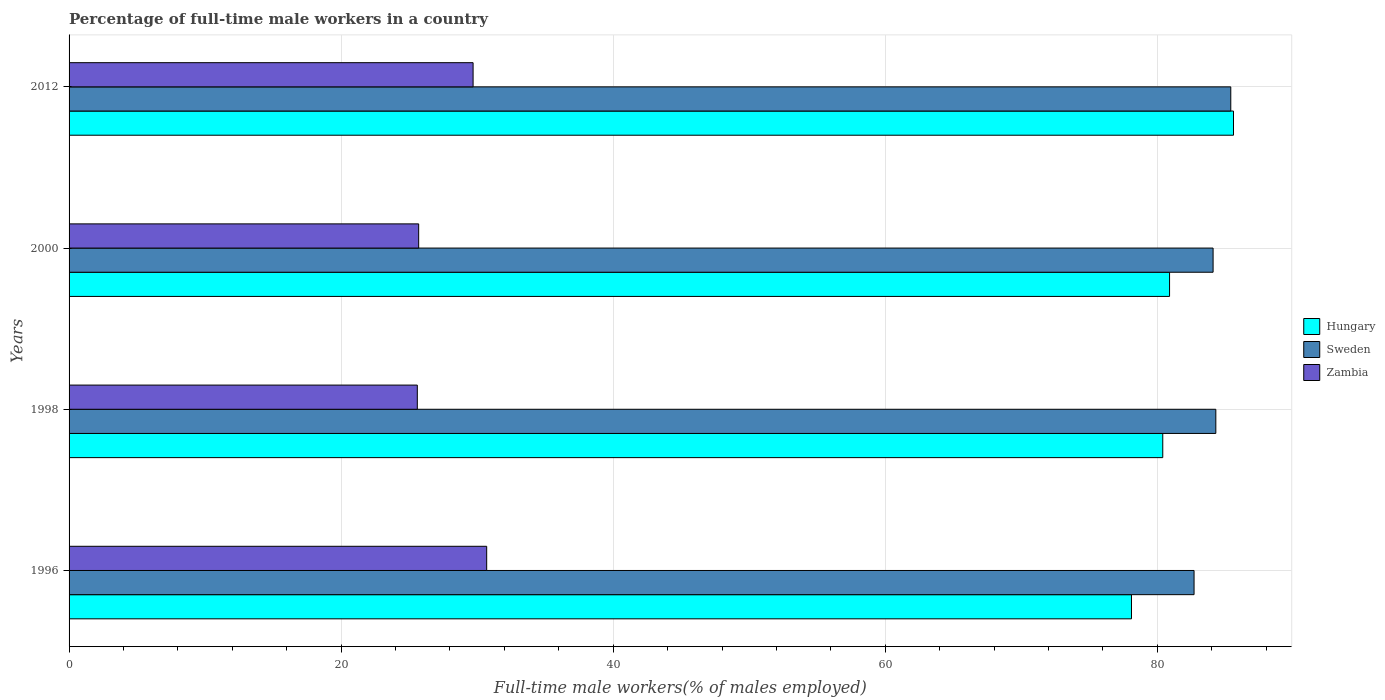How many different coloured bars are there?
Ensure brevity in your answer.  3. Are the number of bars on each tick of the Y-axis equal?
Keep it short and to the point. Yes. How many bars are there on the 4th tick from the top?
Keep it short and to the point. 3. How many bars are there on the 2nd tick from the bottom?
Your response must be concise. 3. What is the percentage of full-time male workers in Zambia in 1996?
Ensure brevity in your answer.  30.7. Across all years, what is the maximum percentage of full-time male workers in Sweden?
Your answer should be very brief. 85.4. Across all years, what is the minimum percentage of full-time male workers in Zambia?
Your response must be concise. 25.6. In which year was the percentage of full-time male workers in Zambia maximum?
Offer a very short reply. 1996. In which year was the percentage of full-time male workers in Sweden minimum?
Provide a succinct answer. 1996. What is the total percentage of full-time male workers in Sweden in the graph?
Provide a succinct answer. 336.5. What is the difference between the percentage of full-time male workers in Zambia in 2000 and the percentage of full-time male workers in Sweden in 1998?
Keep it short and to the point. -58.6. What is the average percentage of full-time male workers in Sweden per year?
Provide a short and direct response. 84.12. In the year 1996, what is the difference between the percentage of full-time male workers in Zambia and percentage of full-time male workers in Hungary?
Provide a succinct answer. -47.4. In how many years, is the percentage of full-time male workers in Zambia greater than 64 %?
Offer a very short reply. 0. What is the ratio of the percentage of full-time male workers in Zambia in 1996 to that in 2000?
Offer a very short reply. 1.19. Is the percentage of full-time male workers in Hungary in 2000 less than that in 2012?
Give a very brief answer. Yes. What is the difference between the highest and the second highest percentage of full-time male workers in Zambia?
Offer a very short reply. 1. What is the difference between the highest and the lowest percentage of full-time male workers in Hungary?
Give a very brief answer. 7.5. In how many years, is the percentage of full-time male workers in Sweden greater than the average percentage of full-time male workers in Sweden taken over all years?
Provide a succinct answer. 2. What does the 3rd bar from the top in 2000 represents?
Your answer should be very brief. Hungary. What does the 3rd bar from the bottom in 2012 represents?
Provide a succinct answer. Zambia. Are all the bars in the graph horizontal?
Offer a terse response. Yes. How many years are there in the graph?
Keep it short and to the point. 4. What is the difference between two consecutive major ticks on the X-axis?
Ensure brevity in your answer.  20. Does the graph contain grids?
Make the answer very short. Yes. How many legend labels are there?
Make the answer very short. 3. How are the legend labels stacked?
Offer a very short reply. Vertical. What is the title of the graph?
Ensure brevity in your answer.  Percentage of full-time male workers in a country. What is the label or title of the X-axis?
Give a very brief answer. Full-time male workers(% of males employed). What is the label or title of the Y-axis?
Make the answer very short. Years. What is the Full-time male workers(% of males employed) of Hungary in 1996?
Your response must be concise. 78.1. What is the Full-time male workers(% of males employed) of Sweden in 1996?
Keep it short and to the point. 82.7. What is the Full-time male workers(% of males employed) of Zambia in 1996?
Give a very brief answer. 30.7. What is the Full-time male workers(% of males employed) of Hungary in 1998?
Provide a succinct answer. 80.4. What is the Full-time male workers(% of males employed) of Sweden in 1998?
Offer a very short reply. 84.3. What is the Full-time male workers(% of males employed) of Zambia in 1998?
Your response must be concise. 25.6. What is the Full-time male workers(% of males employed) in Hungary in 2000?
Ensure brevity in your answer.  80.9. What is the Full-time male workers(% of males employed) of Sweden in 2000?
Offer a very short reply. 84.1. What is the Full-time male workers(% of males employed) in Zambia in 2000?
Give a very brief answer. 25.7. What is the Full-time male workers(% of males employed) in Hungary in 2012?
Make the answer very short. 85.6. What is the Full-time male workers(% of males employed) of Sweden in 2012?
Your answer should be very brief. 85.4. What is the Full-time male workers(% of males employed) in Zambia in 2012?
Provide a succinct answer. 29.7. Across all years, what is the maximum Full-time male workers(% of males employed) of Hungary?
Make the answer very short. 85.6. Across all years, what is the maximum Full-time male workers(% of males employed) of Sweden?
Your response must be concise. 85.4. Across all years, what is the maximum Full-time male workers(% of males employed) in Zambia?
Your answer should be compact. 30.7. Across all years, what is the minimum Full-time male workers(% of males employed) of Hungary?
Give a very brief answer. 78.1. Across all years, what is the minimum Full-time male workers(% of males employed) of Sweden?
Keep it short and to the point. 82.7. Across all years, what is the minimum Full-time male workers(% of males employed) in Zambia?
Your answer should be very brief. 25.6. What is the total Full-time male workers(% of males employed) in Hungary in the graph?
Provide a short and direct response. 325. What is the total Full-time male workers(% of males employed) in Sweden in the graph?
Your answer should be compact. 336.5. What is the total Full-time male workers(% of males employed) of Zambia in the graph?
Provide a succinct answer. 111.7. What is the difference between the Full-time male workers(% of males employed) in Hungary in 1996 and that in 1998?
Your response must be concise. -2.3. What is the difference between the Full-time male workers(% of males employed) in Sweden in 1996 and that in 1998?
Provide a succinct answer. -1.6. What is the difference between the Full-time male workers(% of males employed) in Zambia in 1996 and that in 1998?
Your response must be concise. 5.1. What is the difference between the Full-time male workers(% of males employed) in Sweden in 1996 and that in 2000?
Keep it short and to the point. -1.4. What is the difference between the Full-time male workers(% of males employed) in Zambia in 1996 and that in 2000?
Give a very brief answer. 5. What is the difference between the Full-time male workers(% of males employed) in Hungary in 1996 and that in 2012?
Keep it short and to the point. -7.5. What is the difference between the Full-time male workers(% of males employed) in Sweden in 1996 and that in 2012?
Provide a short and direct response. -2.7. What is the difference between the Full-time male workers(% of males employed) in Sweden in 1998 and that in 2000?
Your answer should be very brief. 0.2. What is the difference between the Full-time male workers(% of males employed) in Zambia in 1998 and that in 2000?
Offer a terse response. -0.1. What is the difference between the Full-time male workers(% of males employed) in Hungary in 1998 and that in 2012?
Provide a short and direct response. -5.2. What is the difference between the Full-time male workers(% of males employed) in Zambia in 1998 and that in 2012?
Provide a succinct answer. -4.1. What is the difference between the Full-time male workers(% of males employed) of Hungary in 2000 and that in 2012?
Offer a terse response. -4.7. What is the difference between the Full-time male workers(% of males employed) in Hungary in 1996 and the Full-time male workers(% of males employed) in Zambia in 1998?
Keep it short and to the point. 52.5. What is the difference between the Full-time male workers(% of males employed) of Sweden in 1996 and the Full-time male workers(% of males employed) of Zambia in 1998?
Your response must be concise. 57.1. What is the difference between the Full-time male workers(% of males employed) of Hungary in 1996 and the Full-time male workers(% of males employed) of Sweden in 2000?
Give a very brief answer. -6. What is the difference between the Full-time male workers(% of males employed) of Hungary in 1996 and the Full-time male workers(% of males employed) of Zambia in 2000?
Offer a very short reply. 52.4. What is the difference between the Full-time male workers(% of males employed) in Sweden in 1996 and the Full-time male workers(% of males employed) in Zambia in 2000?
Ensure brevity in your answer.  57. What is the difference between the Full-time male workers(% of males employed) in Hungary in 1996 and the Full-time male workers(% of males employed) in Zambia in 2012?
Offer a terse response. 48.4. What is the difference between the Full-time male workers(% of males employed) of Sweden in 1996 and the Full-time male workers(% of males employed) of Zambia in 2012?
Ensure brevity in your answer.  53. What is the difference between the Full-time male workers(% of males employed) in Hungary in 1998 and the Full-time male workers(% of males employed) in Sweden in 2000?
Provide a succinct answer. -3.7. What is the difference between the Full-time male workers(% of males employed) of Hungary in 1998 and the Full-time male workers(% of males employed) of Zambia in 2000?
Ensure brevity in your answer.  54.7. What is the difference between the Full-time male workers(% of males employed) in Sweden in 1998 and the Full-time male workers(% of males employed) in Zambia in 2000?
Offer a terse response. 58.6. What is the difference between the Full-time male workers(% of males employed) of Hungary in 1998 and the Full-time male workers(% of males employed) of Sweden in 2012?
Ensure brevity in your answer.  -5. What is the difference between the Full-time male workers(% of males employed) of Hungary in 1998 and the Full-time male workers(% of males employed) of Zambia in 2012?
Ensure brevity in your answer.  50.7. What is the difference between the Full-time male workers(% of males employed) of Sweden in 1998 and the Full-time male workers(% of males employed) of Zambia in 2012?
Provide a short and direct response. 54.6. What is the difference between the Full-time male workers(% of males employed) in Hungary in 2000 and the Full-time male workers(% of males employed) in Sweden in 2012?
Keep it short and to the point. -4.5. What is the difference between the Full-time male workers(% of males employed) of Hungary in 2000 and the Full-time male workers(% of males employed) of Zambia in 2012?
Your answer should be very brief. 51.2. What is the difference between the Full-time male workers(% of males employed) in Sweden in 2000 and the Full-time male workers(% of males employed) in Zambia in 2012?
Ensure brevity in your answer.  54.4. What is the average Full-time male workers(% of males employed) in Hungary per year?
Your response must be concise. 81.25. What is the average Full-time male workers(% of males employed) of Sweden per year?
Offer a terse response. 84.12. What is the average Full-time male workers(% of males employed) of Zambia per year?
Offer a terse response. 27.93. In the year 1996, what is the difference between the Full-time male workers(% of males employed) of Hungary and Full-time male workers(% of males employed) of Zambia?
Make the answer very short. 47.4. In the year 1998, what is the difference between the Full-time male workers(% of males employed) in Hungary and Full-time male workers(% of males employed) in Zambia?
Provide a short and direct response. 54.8. In the year 1998, what is the difference between the Full-time male workers(% of males employed) in Sweden and Full-time male workers(% of males employed) in Zambia?
Offer a very short reply. 58.7. In the year 2000, what is the difference between the Full-time male workers(% of males employed) of Hungary and Full-time male workers(% of males employed) of Sweden?
Offer a terse response. -3.2. In the year 2000, what is the difference between the Full-time male workers(% of males employed) of Hungary and Full-time male workers(% of males employed) of Zambia?
Your response must be concise. 55.2. In the year 2000, what is the difference between the Full-time male workers(% of males employed) in Sweden and Full-time male workers(% of males employed) in Zambia?
Ensure brevity in your answer.  58.4. In the year 2012, what is the difference between the Full-time male workers(% of males employed) of Hungary and Full-time male workers(% of males employed) of Zambia?
Offer a very short reply. 55.9. In the year 2012, what is the difference between the Full-time male workers(% of males employed) in Sweden and Full-time male workers(% of males employed) in Zambia?
Provide a succinct answer. 55.7. What is the ratio of the Full-time male workers(% of males employed) in Hungary in 1996 to that in 1998?
Provide a succinct answer. 0.97. What is the ratio of the Full-time male workers(% of males employed) in Sweden in 1996 to that in 1998?
Provide a short and direct response. 0.98. What is the ratio of the Full-time male workers(% of males employed) in Zambia in 1996 to that in 1998?
Make the answer very short. 1.2. What is the ratio of the Full-time male workers(% of males employed) of Hungary in 1996 to that in 2000?
Offer a very short reply. 0.97. What is the ratio of the Full-time male workers(% of males employed) of Sweden in 1996 to that in 2000?
Keep it short and to the point. 0.98. What is the ratio of the Full-time male workers(% of males employed) of Zambia in 1996 to that in 2000?
Offer a terse response. 1.19. What is the ratio of the Full-time male workers(% of males employed) in Hungary in 1996 to that in 2012?
Offer a terse response. 0.91. What is the ratio of the Full-time male workers(% of males employed) of Sweden in 1996 to that in 2012?
Make the answer very short. 0.97. What is the ratio of the Full-time male workers(% of males employed) of Zambia in 1996 to that in 2012?
Your answer should be very brief. 1.03. What is the ratio of the Full-time male workers(% of males employed) in Sweden in 1998 to that in 2000?
Ensure brevity in your answer.  1. What is the ratio of the Full-time male workers(% of males employed) of Hungary in 1998 to that in 2012?
Give a very brief answer. 0.94. What is the ratio of the Full-time male workers(% of males employed) of Sweden in 1998 to that in 2012?
Offer a terse response. 0.99. What is the ratio of the Full-time male workers(% of males employed) in Zambia in 1998 to that in 2012?
Offer a very short reply. 0.86. What is the ratio of the Full-time male workers(% of males employed) in Hungary in 2000 to that in 2012?
Ensure brevity in your answer.  0.95. What is the ratio of the Full-time male workers(% of males employed) in Zambia in 2000 to that in 2012?
Provide a short and direct response. 0.87. What is the difference between the highest and the second highest Full-time male workers(% of males employed) in Sweden?
Give a very brief answer. 1.1. What is the difference between the highest and the lowest Full-time male workers(% of males employed) in Hungary?
Make the answer very short. 7.5. What is the difference between the highest and the lowest Full-time male workers(% of males employed) in Sweden?
Provide a short and direct response. 2.7. 